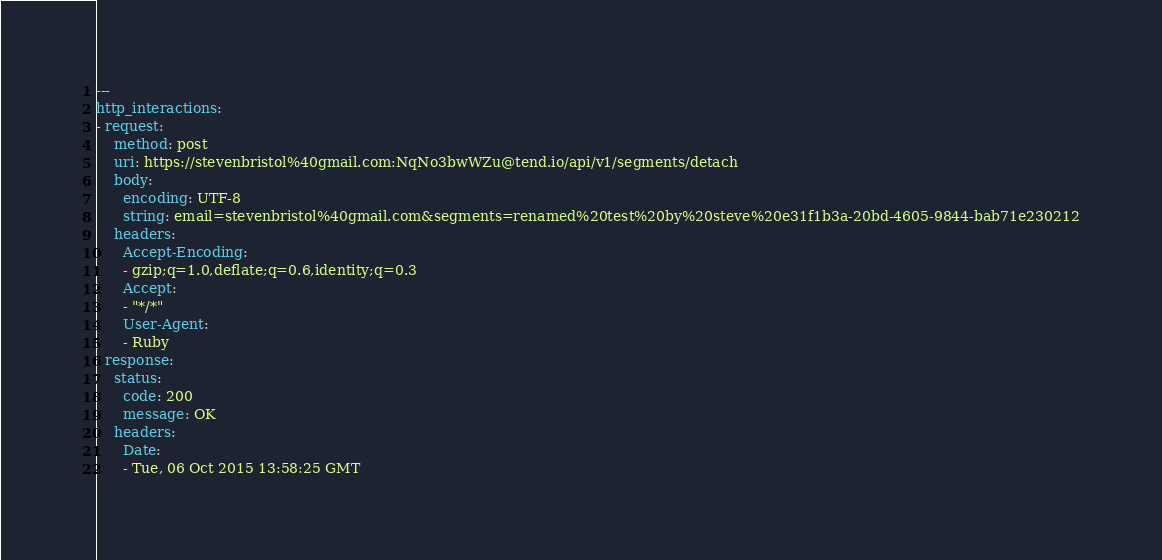Convert code to text. <code><loc_0><loc_0><loc_500><loc_500><_YAML_>---
http_interactions:
- request:
    method: post
    uri: https://stevenbristol%40gmail.com:NqNo3bwWZu@tend.io/api/v1/segments/detach
    body:
      encoding: UTF-8
      string: email=stevenbristol%40gmail.com&segments=renamed%20test%20by%20steve%20e31f1b3a-20bd-4605-9844-bab71e230212
    headers:
      Accept-Encoding:
      - gzip;q=1.0,deflate;q=0.6,identity;q=0.3
      Accept:
      - "*/*"
      User-Agent:
      - Ruby
  response:
    status:
      code: 200
      message: OK
    headers:
      Date:
      - Tue, 06 Oct 2015 13:58:25 GMT</code> 